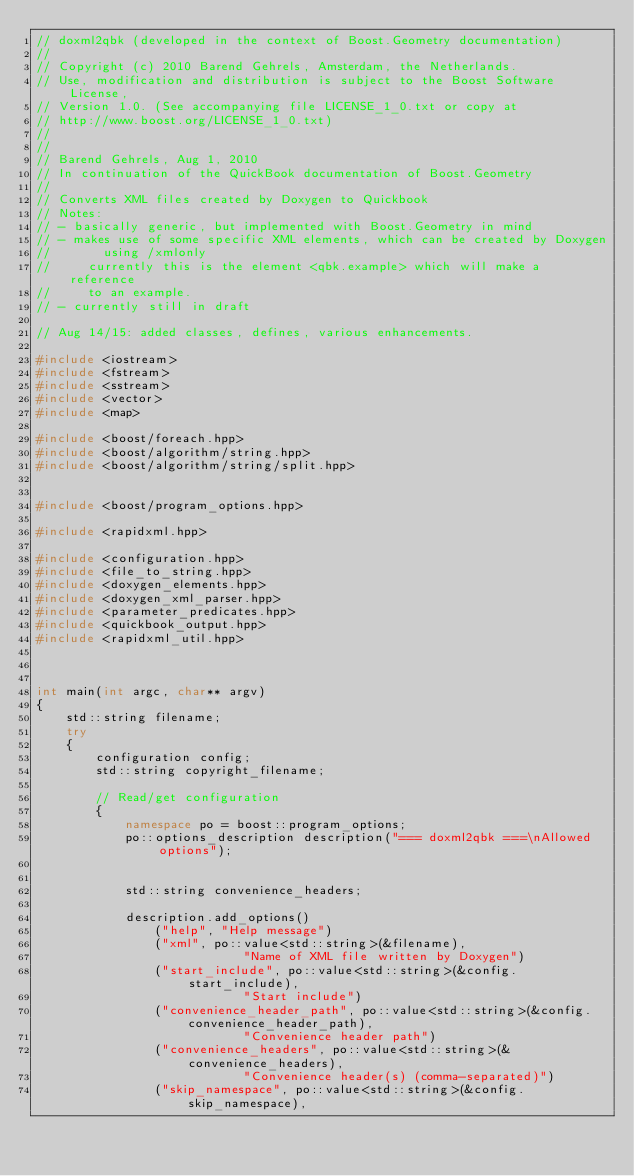Convert code to text. <code><loc_0><loc_0><loc_500><loc_500><_C++_>// doxml2qbk (developed in the context of Boost.Geometry documentation)
//
// Copyright (c) 2010 Barend Gehrels, Amsterdam, the Netherlands.
// Use, modification and distribution is subject to the Boost Software License,
// Version 1.0. (See accompanying file LICENSE_1_0.txt or copy at
// http://www.boost.org/LICENSE_1_0.txt)
//
//
// Barend Gehrels, Aug 1, 2010
// In continuation of the QuickBook documentation of Boost.Geometry
//
// Converts XML files created by Doxygen to Quickbook
// Notes:
// - basically generic, but implemented with Boost.Geometry in mind
// - makes use of some specific XML elements, which can be created by Doxygen
//       using /xmlonly
//     currently this is the element <qbk.example> which will make a reference
//     to an example.
// - currently still in draft

// Aug 14/15: added classes, defines, various enhancements.

#include <iostream>
#include <fstream>
#include <sstream>
#include <vector>
#include <map>

#include <boost/foreach.hpp>
#include <boost/algorithm/string.hpp>
#include <boost/algorithm/string/split.hpp>


#include <boost/program_options.hpp>

#include <rapidxml.hpp>

#include <configuration.hpp>
#include <file_to_string.hpp>
#include <doxygen_elements.hpp>
#include <doxygen_xml_parser.hpp>
#include <parameter_predicates.hpp>
#include <quickbook_output.hpp>
#include <rapidxml_util.hpp>



int main(int argc, char** argv)
{
    std::string filename;
    try
    {
        configuration config;
        std::string copyright_filename;

        // Read/get configuration
        {
            namespace po = boost::program_options;
            po::options_description description("=== doxml2qbk ===\nAllowed options");


            std::string convenience_headers;

            description.add_options()
                ("help", "Help message")
                ("xml", po::value<std::string>(&filename), 
                            "Name of XML file written by Doxygen")
                ("start_include", po::value<std::string>(&config.start_include), 
                            "Start include")
                ("convenience_header_path", po::value<std::string>(&config.convenience_header_path), 
                            "Convenience header path")
                ("convenience_headers", po::value<std::string>(&convenience_headers), 
                            "Convenience header(s) (comma-separated)")
                ("skip_namespace", po::value<std::string>(&config.skip_namespace), </code> 